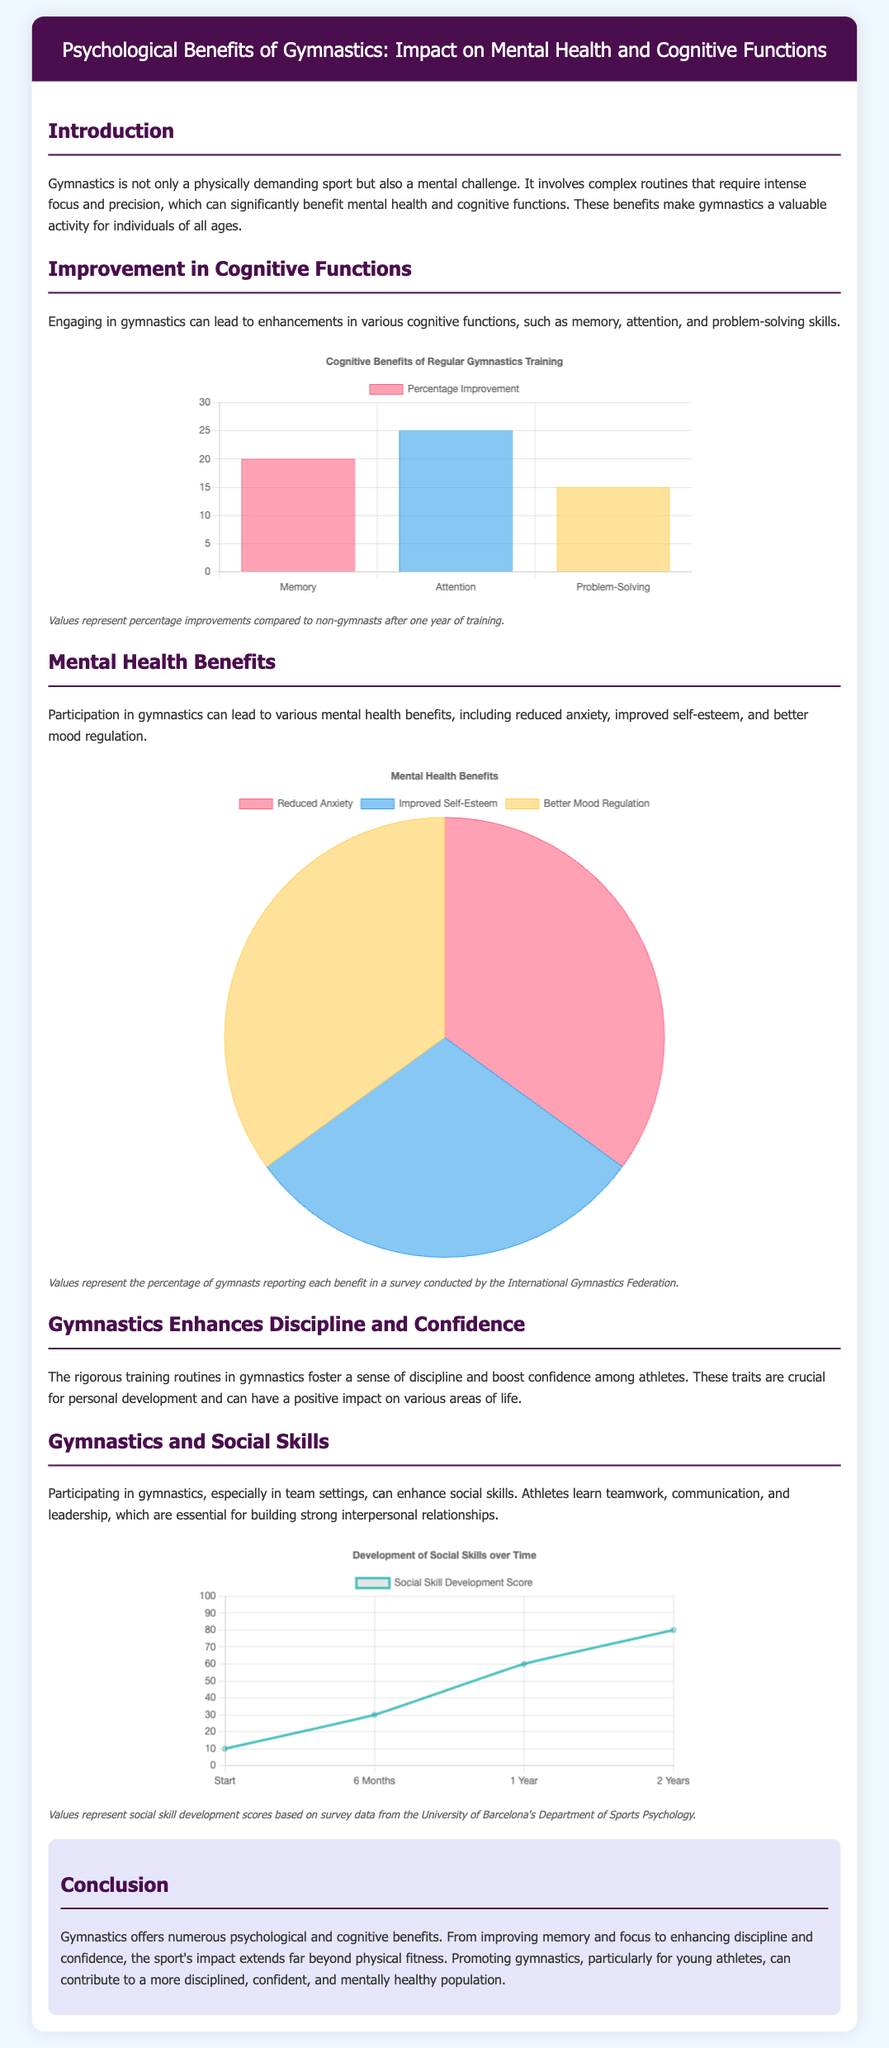What are the three cognitive functions improved by gymnastics? The document lists memory, attention, and problem-solving as the cognitive functions improved by gymnastics.
Answer: Memory, Attention, Problem-Solving What is the percentage improvement of attention compared to non-gymnasts? According to the chart, the percentage improvement for attention is 25%.
Answer: 25% What mental health benefit has the highest percentage reported by gymnasts? Based on the pie chart, reduced anxiety and better mood regulation both have the highest percentage along with improved self-esteem.
Answer: Reduced Anxiety What is the social skill development score after one year of gymnastics training? The score after one year of training, according to the line chart, is 60.
Answer: 60 What is the maximum value indicated on the y-axis of the Cognitive Benefits chart? The maximum value indicated on the y-axis of the Cognitive Benefits chart is 30.
Answer: 30 How many years are represented in the Social Skills Development chart? The timeline represented in the Social Skills Development chart ranges from the start to 2 years.
Answer: 2 Years What are the three mental health benefits listed in the document? The document outlines reduced anxiety, improved self-esteem, and better mood regulation as the mental health benefits.
Answer: Reduced Anxiety, Improved Self-Esteem, Better Mood Regulation What is the primary focus of the conclusions drawn in the document? The focus of the conclusions is on the numerous psychological and cognitive benefits that gymnastics offers.
Answer: Psychological and cognitive benefits What color represents the problem-solving improvement in the Cognitive Benefits chart? The color representing problem-solving improvement in the Cognitive Benefits chart is yellow.
Answer: Yellow 